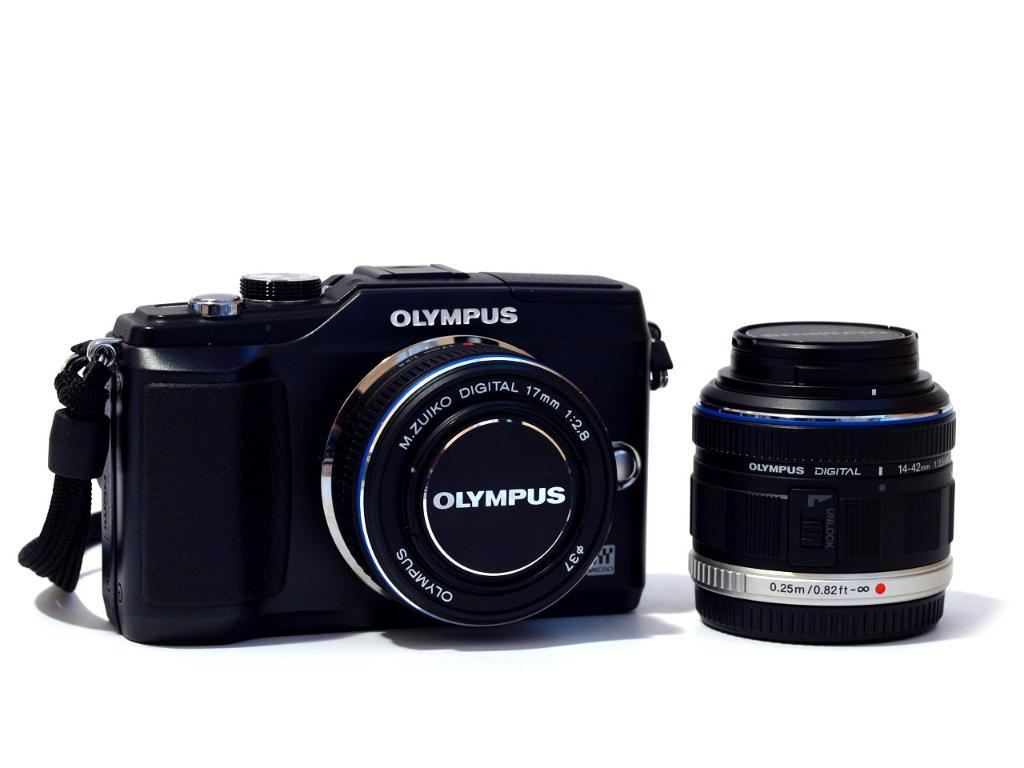What is the main object in the image? There is a camera in the image. What part of the camera is visible in the image? There is a lens in the image. What type of self is depicted in the image? There is no self or person present in the image; it only features a camera and a lens. What is the camera's attention focused on in the image? The camera does not have attention in the image, as it is an inanimate object. 